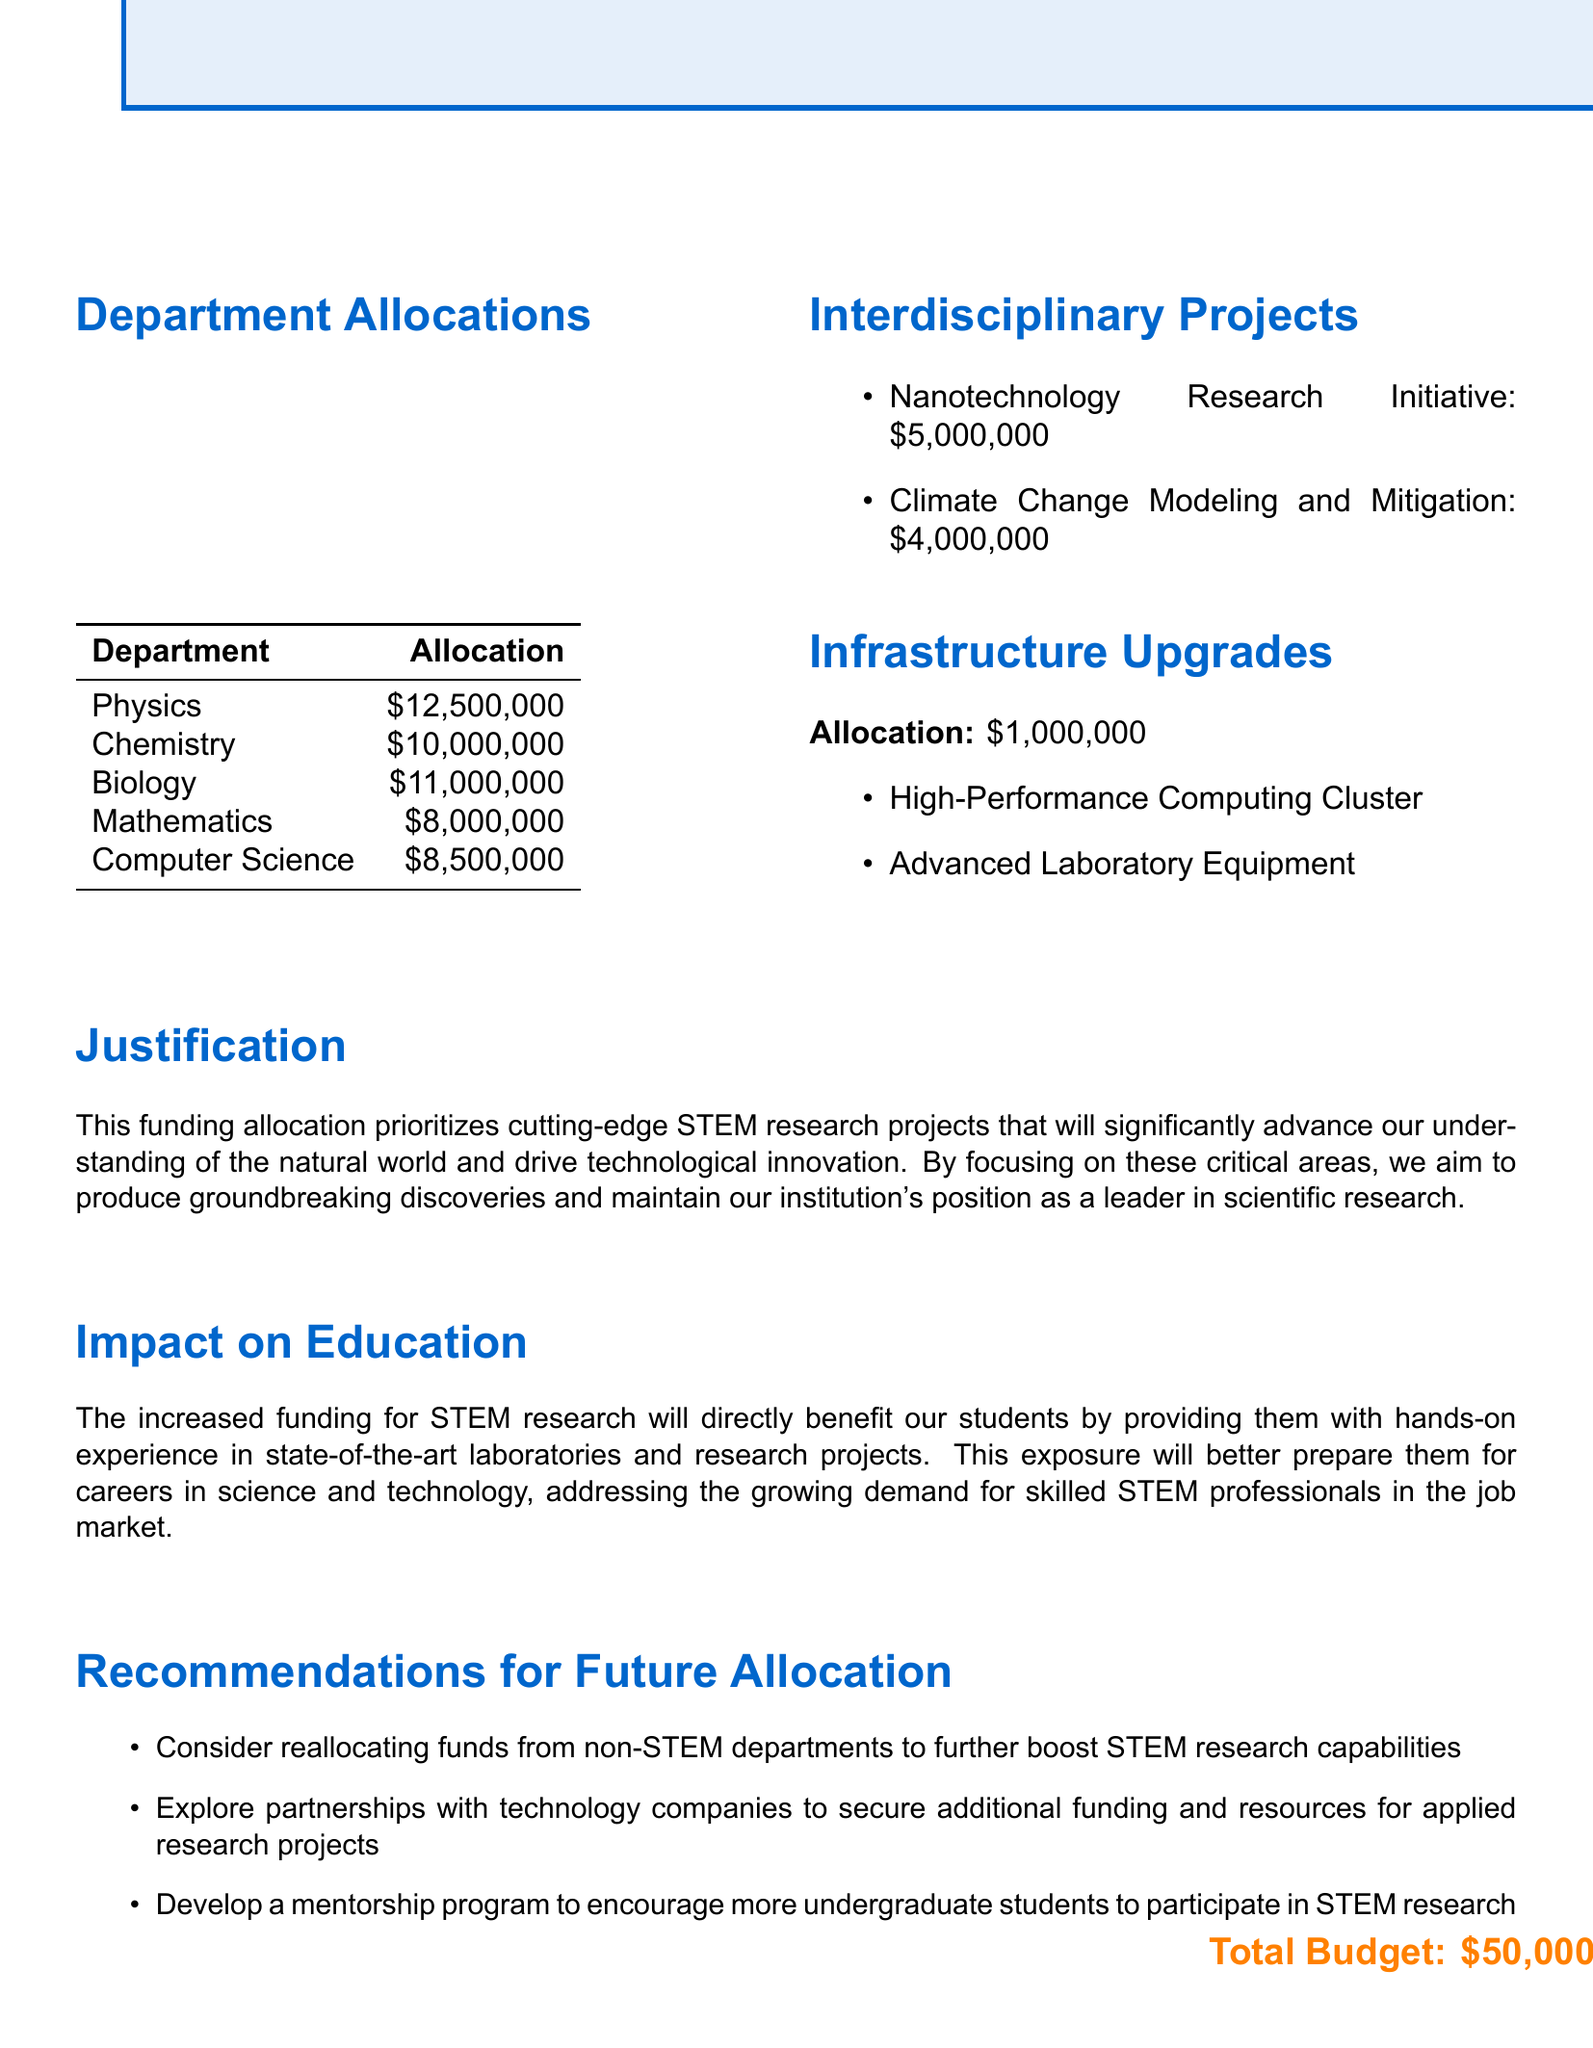What is the total budget for STEM research? The total budget is specified in the document as $50,000,000.
Answer: $50,000,000 How much is allocated to the Department of Chemistry? The allocation for the Department of Chemistry can be found in the department allocations section of the document, which states $10,000,000.
Answer: $10,000,000 What are the major projects for the Department of Biology? The document lists the major projects for the Department of Biology, which are CRISPR Gene Editing Research and Bioinformatics and Genomics Center.
Answer: CRISPR Gene Editing Research, Bioinformatics and Genomics Center Which department has the highest funding allocation? By reviewing the department allocations, the Department of Physics has the highest funding allocation of $12,500,000.
Answer: Department of Physics What is the allocation for interdisciplinary projects? The total allocation for interdisciplinary projects can be determined by adding the specific allocations for the two projects mentioned: Nanotechnology Research Initiative ($5,000,000) and Climate Change Modeling and Mitigation ($4,000,000), giving a total of $9,000,000.
Answer: $9,000,000 What is the purpose of infrastructure upgrades according to the report? The infrastructure upgrades section of the document indicates that the funding is directed towards High-Performance Computing Cluster and Advanced Laboratory Equipment, enhancing research capabilities.
Answer: High-Performance Computing Cluster, Advanced Laboratory Equipment What is one recommendation for future allocation? The document provides several recommendations, one of which is to consider reallocating funds from non-STEM departments to boost STEM research capabilities.
Answer: Reallocating funds from non-STEM departments How will the funding impact student education? The impact on education section details that increased funding will provide students with hands-on experience in laboratories and research projects, preparing them for careers in STEM.
Answer: Hands-on experience in state-of-the-art laboratories What fiscal year is covered in this funding allocation report? The fiscal year specified in the title of the report is 2023-2024.
Answer: 2023-2024 Which department is involved in the Climate Change Modeling and Mitigation project? The interdisciplinary projects section lists the departments involved in the Climate Change Modeling and Mitigation project, indicating that they are Physics, Mathematics, and Computer Science.
Answer: Physics, Mathematics, Computer Science 